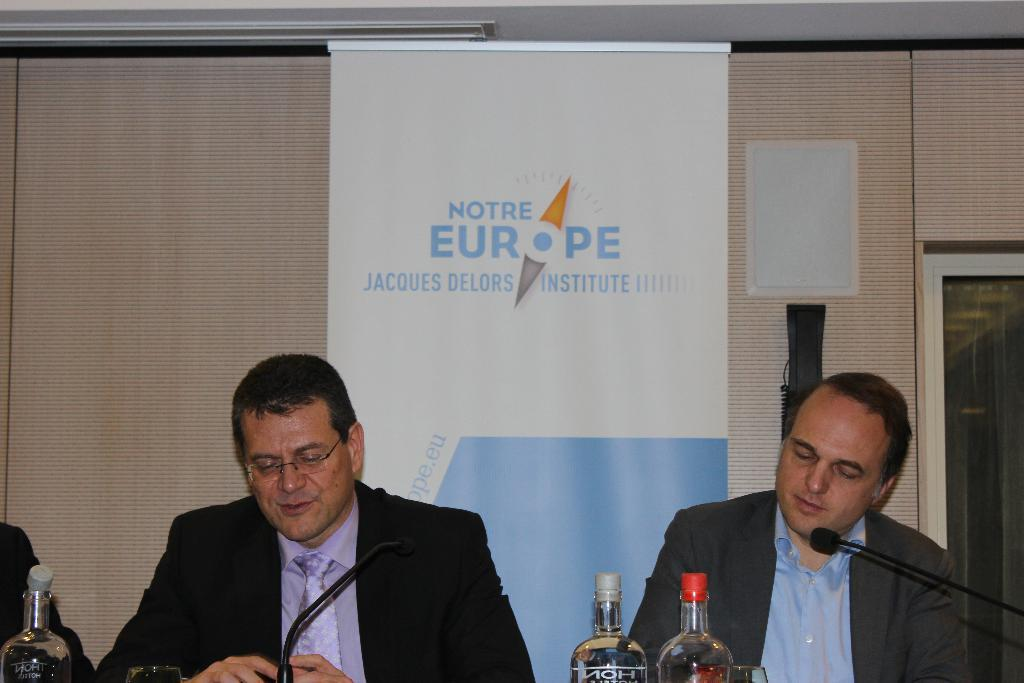Provide a one-sentence caption for the provided image. Two men sitting at a table behind a banner for Notre Europe Jacques Delors Institute. 